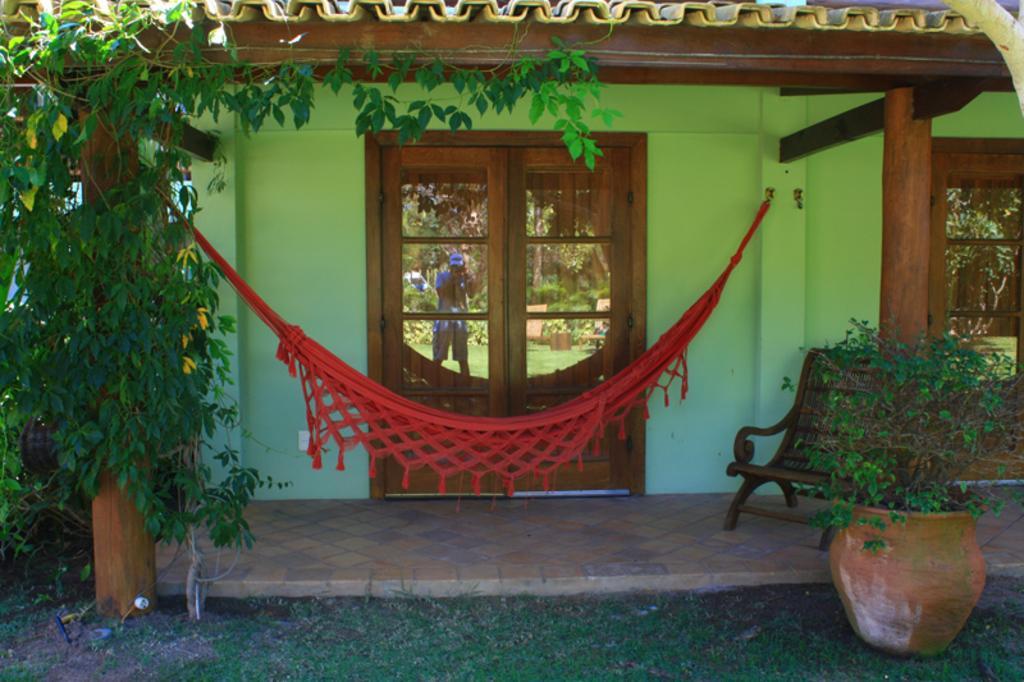In one or two sentences, can you explain what this image depicts? On the right at the bottom corner we can see a plant in a pot on the ground. On the left we can see a plant. This is a house,we can see doors,roof,chair on the floor and a cloth is tied to an object and other end of it is tied to an object on the wall. 